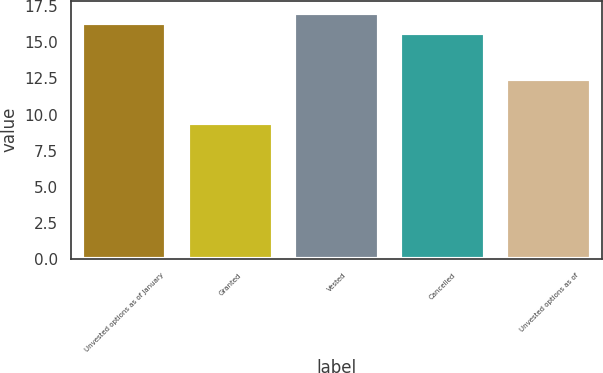Convert chart to OTSL. <chart><loc_0><loc_0><loc_500><loc_500><bar_chart><fcel>Unvested options as of January<fcel>Granted<fcel>Vested<fcel>Cancelled<fcel>Unvested options as of<nl><fcel>16.35<fcel>9.39<fcel>17.03<fcel>15.67<fcel>12.49<nl></chart> 